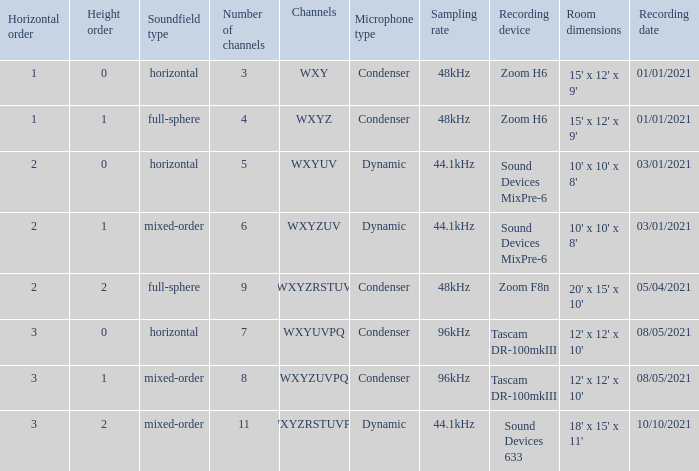If the height order is 1 and the soundfield type is mixed-order, what are all the channels? WXYZUV, WXYZUVPQ. Would you be able to parse every entry in this table? {'header': ['Horizontal order', 'Height order', 'Soundfield type', 'Number of channels', 'Channels', 'Microphone type', 'Sampling rate', 'Recording device', 'Room dimensions', 'Recording date'], 'rows': [['1', '0', 'horizontal', '3', 'WXY', 'Condenser', '48kHz', 'Zoom H6', "15' x 12' x 9'", '01/01/2021'], ['1', '1', 'full-sphere', '4', 'WXYZ', 'Condenser', '48kHz', 'Zoom H6', "15' x 12' x 9'", '01/01/2021'], ['2', '0', 'horizontal', '5', 'WXYUV', 'Dynamic', '44.1kHz', 'Sound Devices MixPre-6', "10' x 10' x 8'", '03/01/2021'], ['2', '1', 'mixed-order', '6', 'WXYZUV', 'Dynamic', '44.1kHz', 'Sound Devices MixPre-6', "10' x 10' x 8'", '03/01/2021'], ['2', '2', 'full-sphere', '9', 'WXYZRSTUV', 'Condenser', '48kHz', 'Zoom F8n', "20' x 15' x 10'", '05/04/2021'], ['3', '0', 'horizontal', '7', 'WXYUVPQ', 'Condenser', '96kHz', 'Tascam DR-100mkIII', "12' x 12' x 10'", '08/05/2021'], ['3', '1', 'mixed-order', '8', 'WXYZUVPQ', 'Condenser', '96kHz', 'Tascam DR-100mkIII', "12' x 12' x 10'", '08/05/2021'], ['3', '2', 'mixed-order', '11', 'WXYZRSTUVPQ', 'Dynamic', '44.1kHz', 'Sound Devices 633', "18' x 15' x 11'", '10/10/2021']]} 